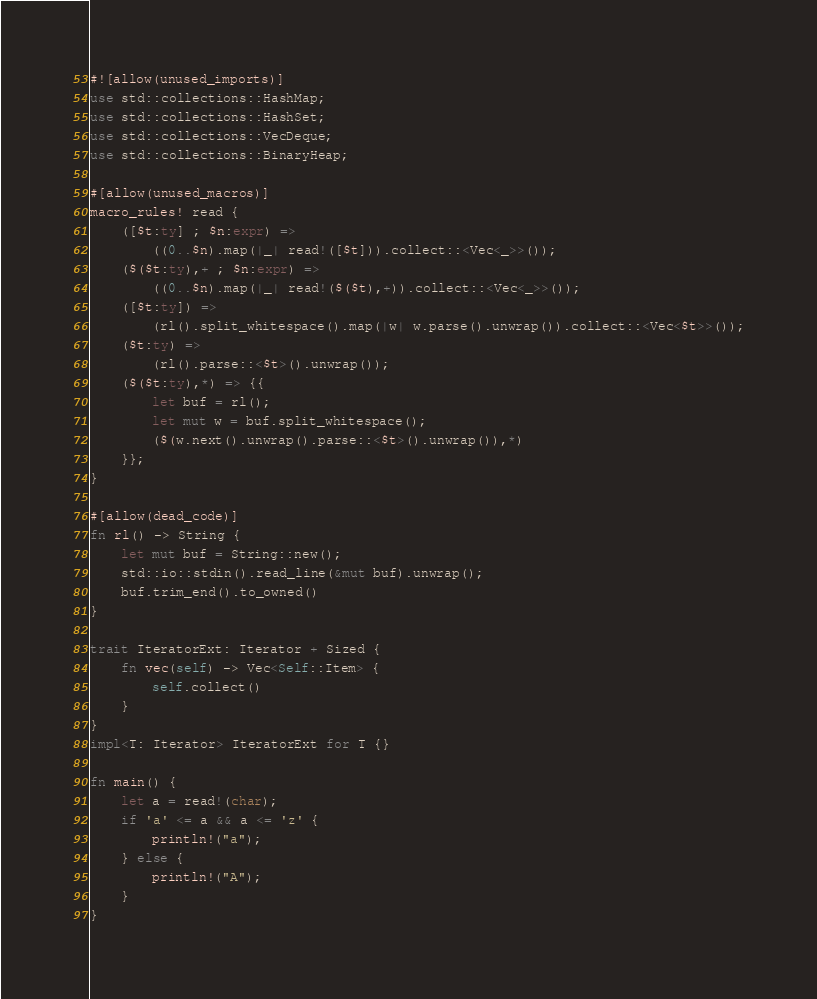<code> <loc_0><loc_0><loc_500><loc_500><_Rust_>#![allow(unused_imports)]
use std::collections::HashMap;
use std::collections::HashSet;
use std::collections::VecDeque;
use std::collections::BinaryHeap;

#[allow(unused_macros)]
macro_rules! read {
    ([$t:ty] ; $n:expr) =>
        ((0..$n).map(|_| read!([$t])).collect::<Vec<_>>());
    ($($t:ty),+ ; $n:expr) =>
        ((0..$n).map(|_| read!($($t),+)).collect::<Vec<_>>());
    ([$t:ty]) =>
        (rl().split_whitespace().map(|w| w.parse().unwrap()).collect::<Vec<$t>>());
    ($t:ty) =>
        (rl().parse::<$t>().unwrap());
    ($($t:ty),*) => {{
        let buf = rl();
        let mut w = buf.split_whitespace();
        ($(w.next().unwrap().parse::<$t>().unwrap()),*)
    }};
}

#[allow(dead_code)]
fn rl() -> String {
    let mut buf = String::new();
    std::io::stdin().read_line(&mut buf).unwrap();
    buf.trim_end().to_owned()
}

trait IteratorExt: Iterator + Sized {
    fn vec(self) -> Vec<Self::Item> {
        self.collect()
    }
}
impl<T: Iterator> IteratorExt for T {}

fn main() {
    let a = read!(char);
    if 'a' <= a && a <= 'z' {
        println!("a");
    } else {
        println!("A");
    }
}

</code> 